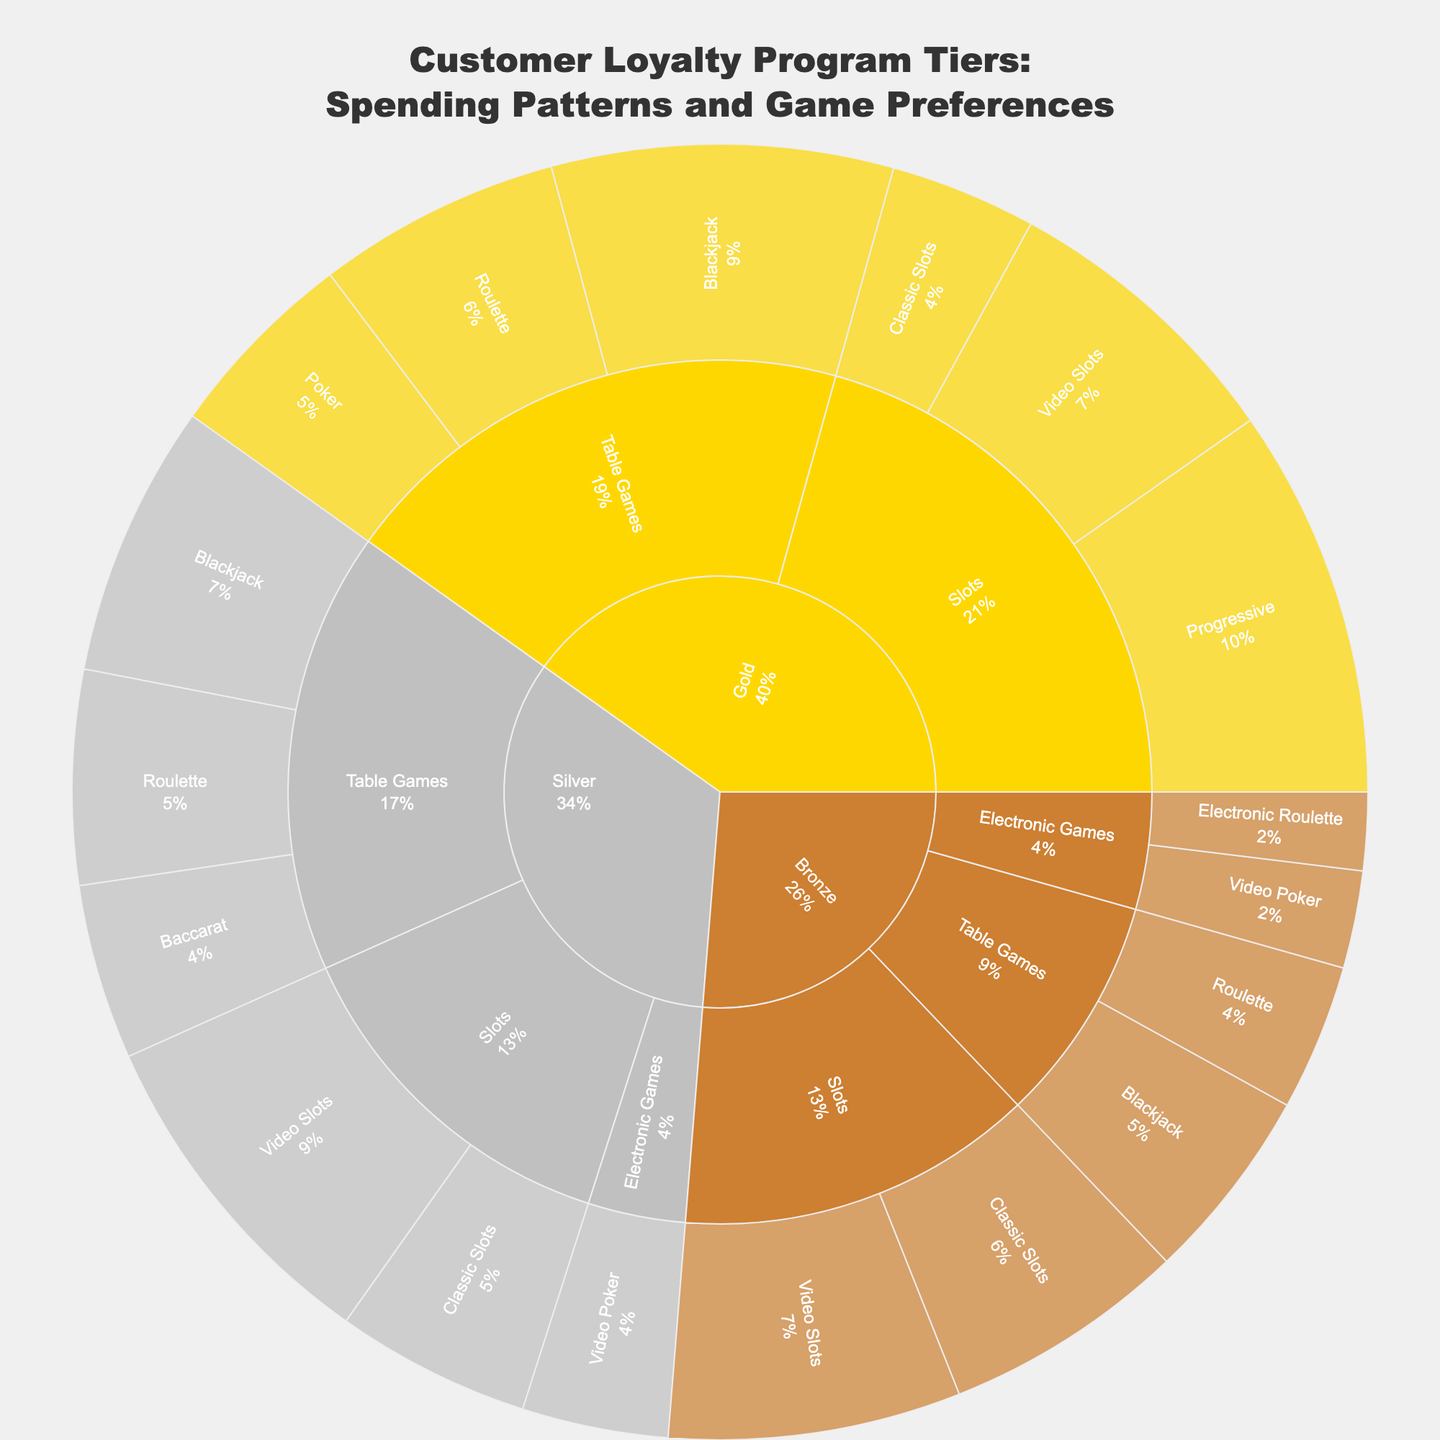What is the most common game preference for Gold tier customers? The sunburst plot shows the spending on various games across different loyalty tiers. Under Gold tier customers, the largest segment is for Progressive Slots.
Answer: Progressive Slots How much do Silver tier customers spend on Table Games? The plot shows different segments for Silver tier customers based on game type and specific game. Adding up the values spent on Blackjack, Roulette, and Baccarat will give the total for Table Games: 28 (Blackjack) + 22 (Roulette) + 18 (Baccarat) = 68.
Answer: 68 Which tier has the highest spending on Classic Slots? The plot shows spending on Classic Slots for different tiers. For Classic Slots, the spending is 15 for Gold, 20 for Silver, and 25 for Bronze.
Answer: Bronze Compare the spending on Video Poker between Silver and Bronze tiers. Which is higher? The plot shows that Silver tier customers spend 15 on Video Poker, while Bronze tier customers spend 10 on Video Poker.
Answer: Silver What percentage of total Gold tier spending is on Table Games? First, add the total spending for Gold tier: 35 (Blackjack) + 25 (Roulette) + 20 (Poker) + 40 (Progressive Slots) + 30 (Video Slots) + 15 (Classic Slots). Then calculate the total spending on Table Games: 35 + 25 + 20. The percentage is (35 + 25 + 20) / (35 + 25 + 20 + 40 + 30 + 15) = 80 / 165 ≈ 48.48%.
Answer: 48.48% What is the most popular game category across all tiers? Summing up the values for all game categories across all tiers: Table Games, Slots, and Electronic Games. The plot shows that the largest combined value belongs to Slots.
Answer: Slots What is the combined spending on Roulette across all tiers? The plot shows Roulette spending as 25 (Gold) + 22 (Silver) + 15 (Bronze). Summing these gives 25 + 22 + 15 = 62.
Answer: 62 Which specific game within Table Games has the highest spending among all tiers? The plot shows that within Table Games, Blackjack has the highest value across different tiers. Adding up Blackjack spending gives 35 (Gold) + 28 (Silver) + 20 (Bronze) = 83.
Answer: Blackjack What is the distribution of spending between different Slot types within the Bronze tier? The plot shows three segments for Slots spending within Bronze: 30 (Video Slots), 25 (Classic Slots). To get the distribution, find the total spending on Slots: 30 (Video Slots) + 25 (Classic Slots) = 55. Then, calculate the percentages: Video Slots = 30/55 ≈ 54.55%, Classic Slots = 25/55 ≈ 45.45%.
Answer: Video Slots: 54.55%, Classic Slots: 45.45% How does the spending on Progressive Slots in the Gold tier compare to the total spending on Electronic Games in the Bronze tier? The plot shows Progressive Slots spending in the Gold tier as 40, and for Bronze tier, Video Poker (Electronic Games) is 10, and Electronic Roulette is 8, totalling 10+8=18. Comparing the two values shows that Progressive Slots spending in the Gold tier is higher.
Answer: Progressive Slots in Gold is higher 